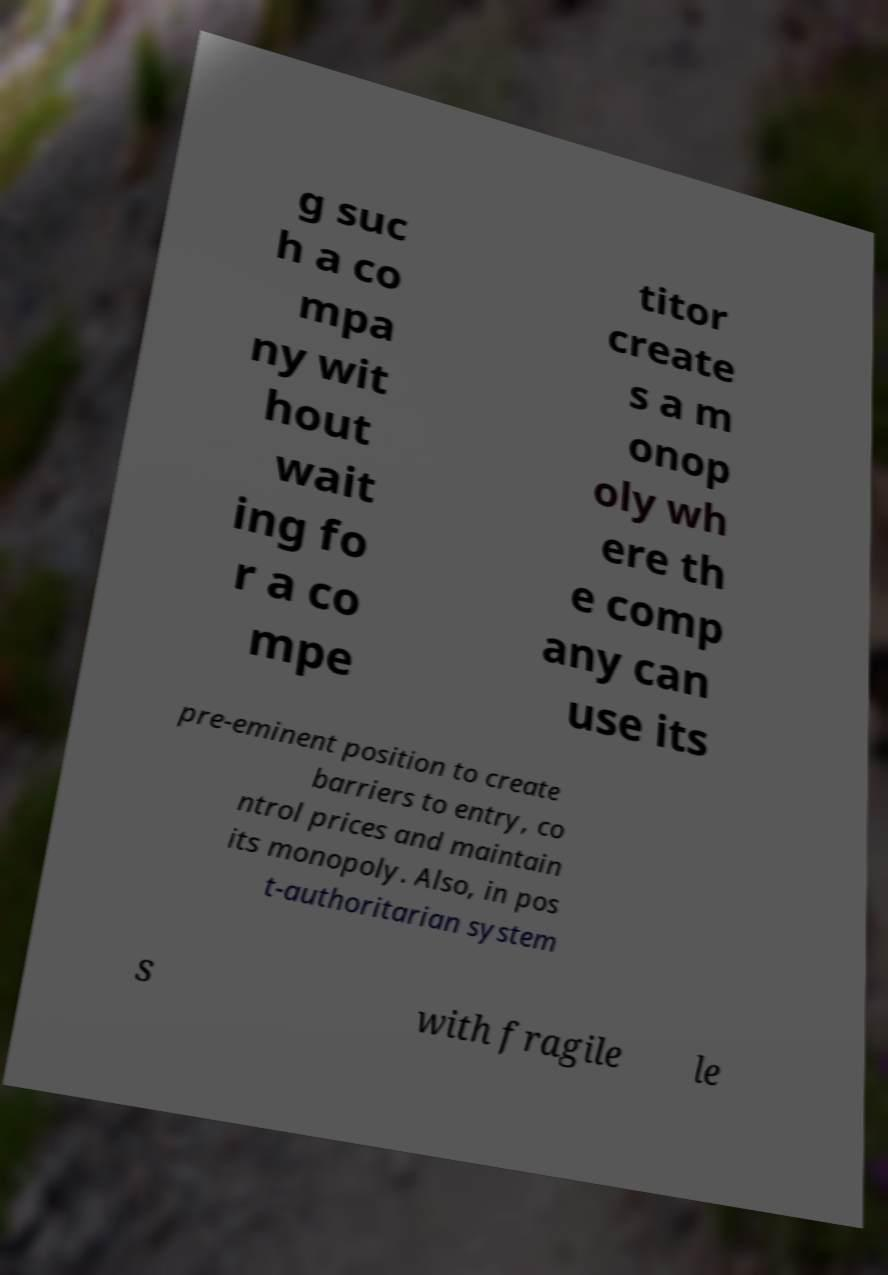Could you assist in decoding the text presented in this image and type it out clearly? g suc h a co mpa ny wit hout wait ing fo r a co mpe titor create s a m onop oly wh ere th e comp any can use its pre-eminent position to create barriers to entry, co ntrol prices and maintain its monopoly. Also, in pos t-authoritarian system s with fragile le 